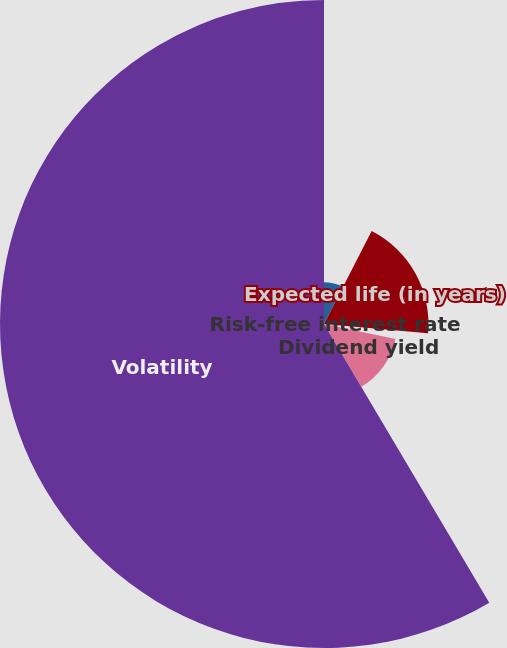Convert chart. <chart><loc_0><loc_0><loc_500><loc_500><pie_chart><fcel>Estimated values<fcel>Expected life (in years)<fcel>Risk-free interest rate<fcel>Dividend yield<fcel>Volatility<nl><fcel>7.54%<fcel>18.87%<fcel>1.87%<fcel>13.2%<fcel>58.52%<nl></chart> 